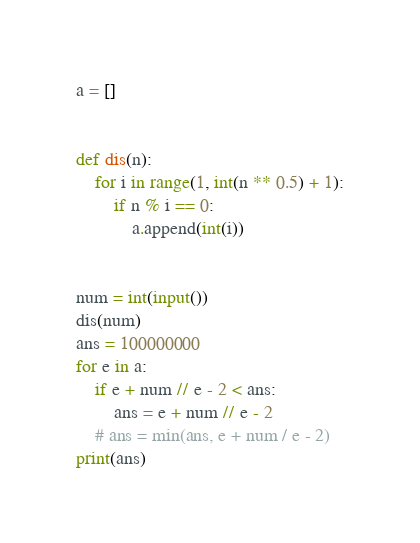Convert code to text. <code><loc_0><loc_0><loc_500><loc_500><_Python_>a = []


def dis(n):
    for i in range(1, int(n ** 0.5) + 1):
        if n % i == 0:
            a.append(int(i))


num = int(input())
dis(num)
ans = 100000000
for e in a:
    if e + num // e - 2 < ans:
        ans = e + num // e - 2
    # ans = min(ans, e + num / e - 2)
print(ans)
</code> 